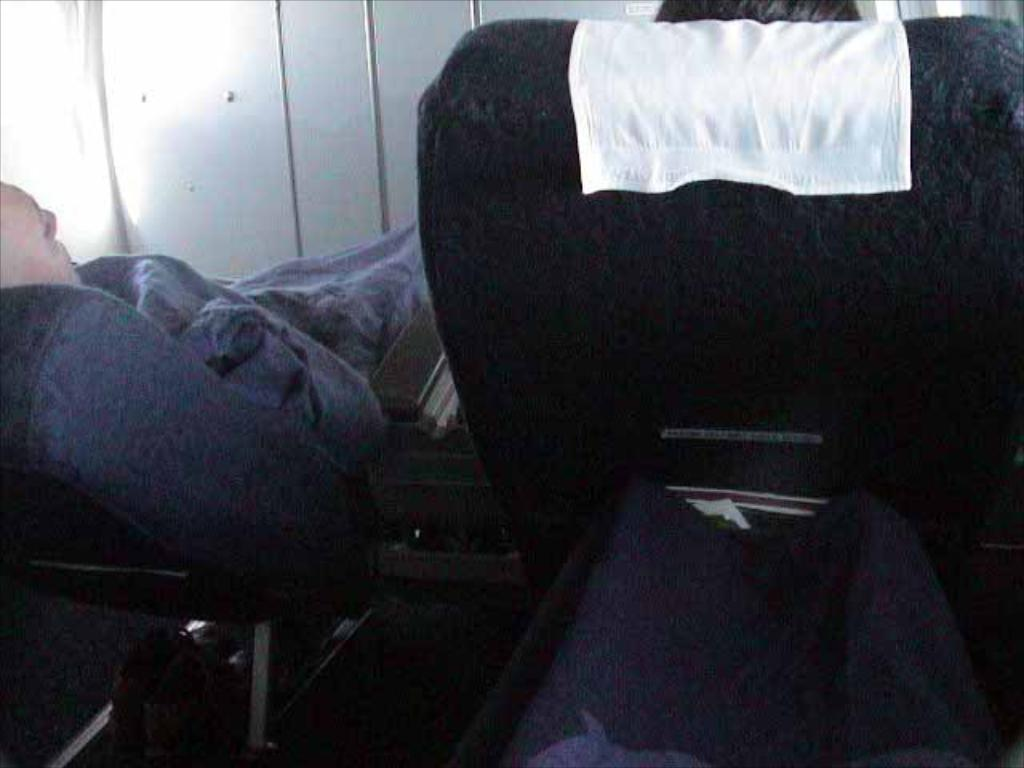What type of furniture is present in the image? There are seats in the image. What are the people on the seats doing? There are people lying on the seats. What can be seen in the background of the image? There is a curtain and a wall in the background of the image. What type of flesh can be seen on the people lying on the seats? There is no mention of flesh in the image, and it is not appropriate to describe people in such a way. 